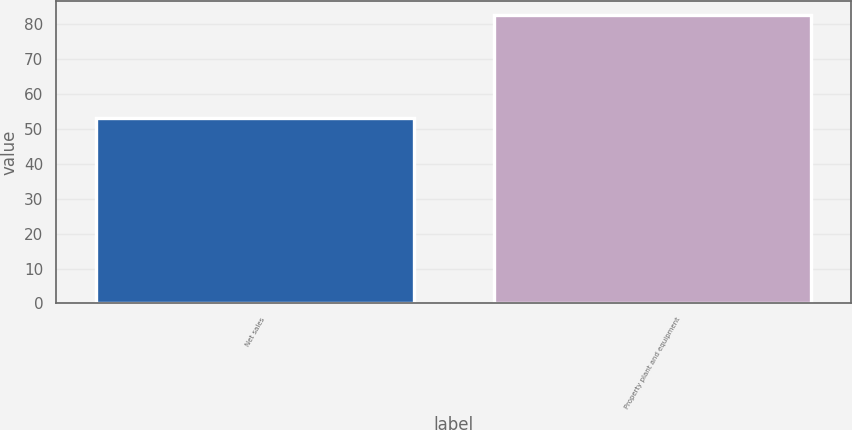Convert chart. <chart><loc_0><loc_0><loc_500><loc_500><bar_chart><fcel>Net sales<fcel>Property plant and equipment<nl><fcel>53.2<fcel>82.5<nl></chart> 